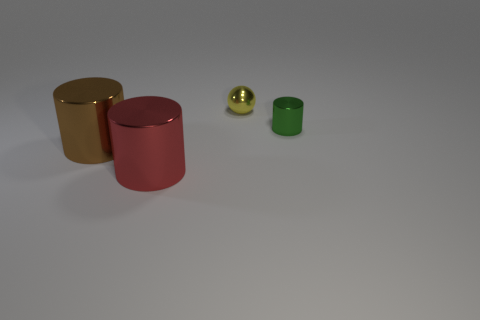Add 4 brown cylinders. How many objects exist? 8 Subtract all cylinders. How many objects are left? 1 Subtract all big metal things. Subtract all small green cylinders. How many objects are left? 1 Add 1 shiny cylinders. How many shiny cylinders are left? 4 Add 4 big matte objects. How many big matte objects exist? 4 Subtract 0 blue balls. How many objects are left? 4 